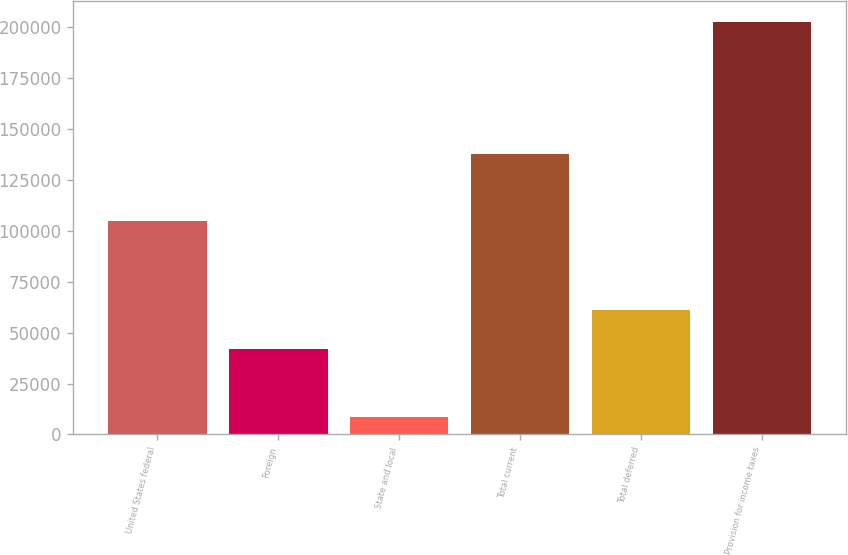<chart> <loc_0><loc_0><loc_500><loc_500><bar_chart><fcel>United States federal<fcel>Foreign<fcel>State and local<fcel>Total current<fcel>Total deferred<fcel>Provision for income taxes<nl><fcel>104587<fcel>41724<fcel>8769<fcel>137542<fcel>61085.4<fcel>202383<nl></chart> 